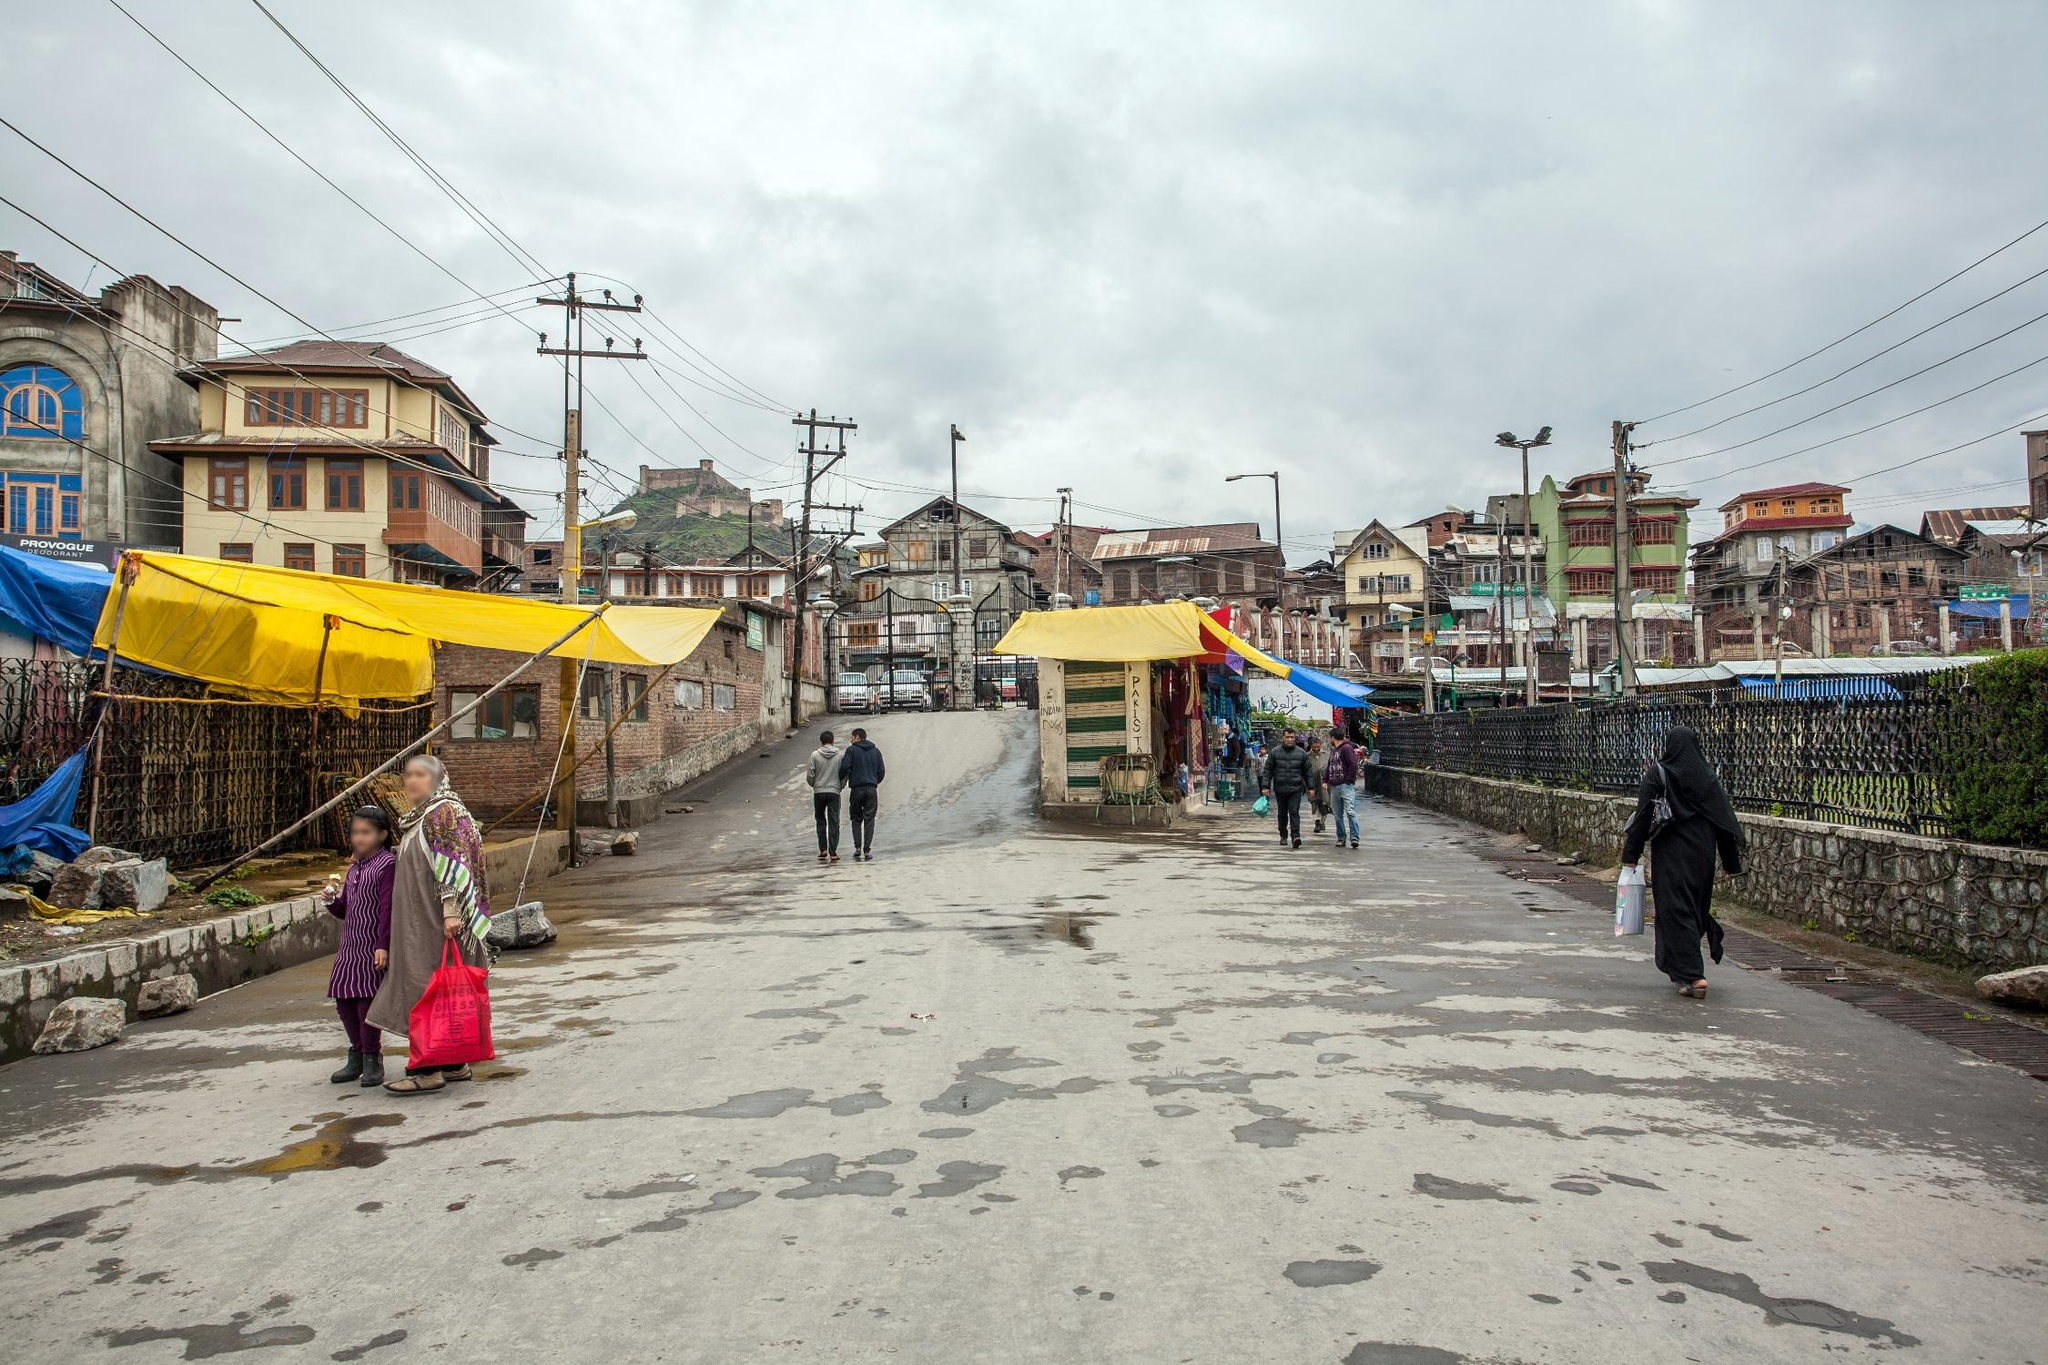Describe the buildings in the background. The buildings in the background are a mix of traditional and modern architectural styles. They are mostly multi-storied, made of brick and wood, with a variety of colors that bring a touch of cheerfulness to the scene. Some have intricate wooden balconies and windows, reflecting the local Kashmiri architecture. The vibrant colors and diverse structures create a rich, visually engaging backdrop to the image. 